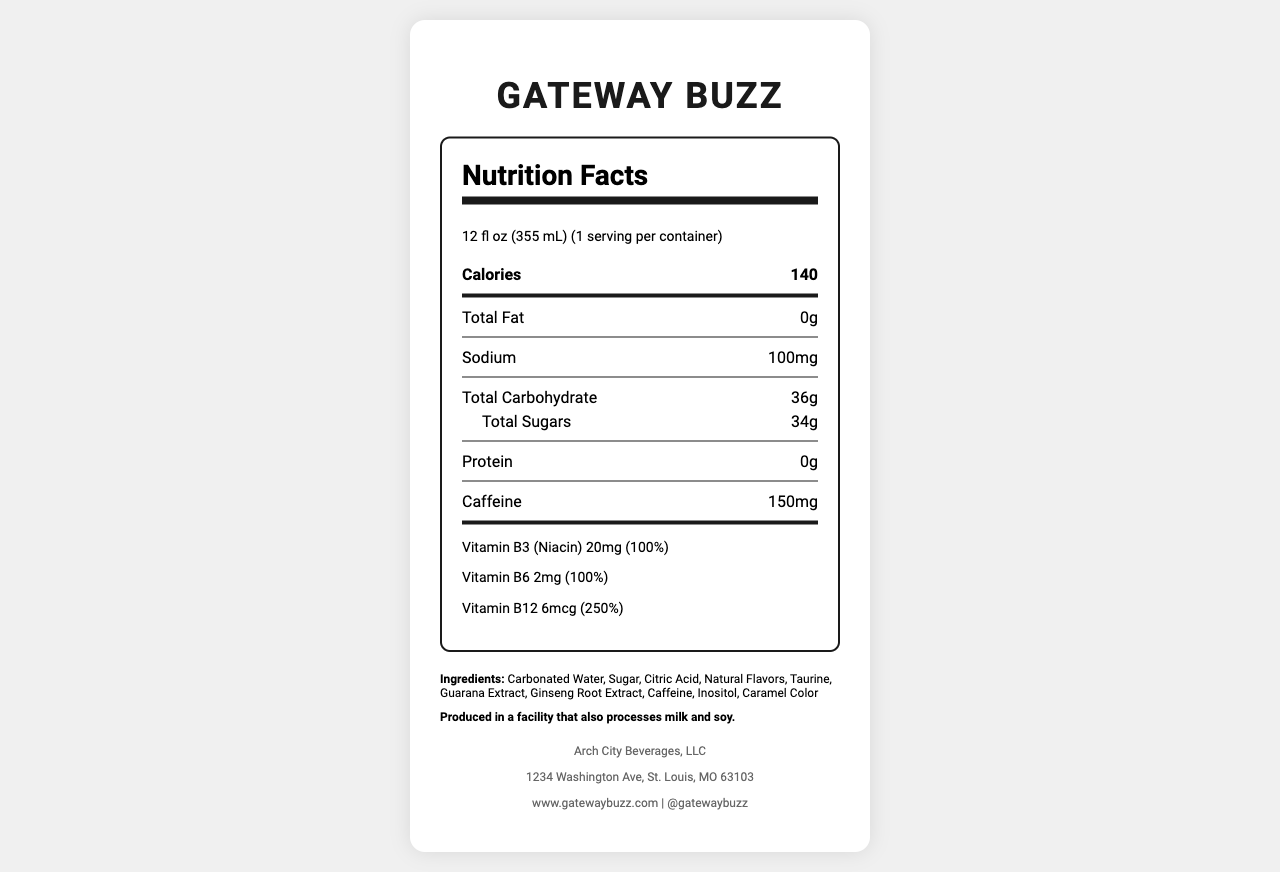what is the serving size for Gateway Buzz? The serving size is listed at the top of the Nutrition Facts section: "12 fl oz (355 mL)".
Answer: 12 fl oz (355 mL) how many servings per container are there? It says "serving per container" which is 1 next to the serving size information.
Answer: 1 how many calories are in one serving of Gateway Buzz? The number of calories is listed in bold under the serving size: "Calories 140".
Answer: 140 what is the total amount of sugars in the drink? Under the Total Carbohydrate section, it specifies "Total Sugars 34g".
Answer: 34g how much caffeine does Gateway Buzz contain? The amount of caffeine is specified separately as "Caffeine 150mg".
Answer: 150mg which vitamins are provided and at what percentage of the daily value? The Vitamins and Minerals section details the amounts and the corresponding daily values.
Answer: Vitamin B3 (Niacin) - 100%, Vitamin B6 - 100%, Vitamin B12 - 250% what are the main ingredients found in Gateway Buzz? A. Carbonated Water, B. Sugar, C. Citric Acid, D. Natural Flavors All the listed ingredients are part of the "other ingredients" section of Gateway Buzz.
Answer: all of the above what is the primary flavor profile of Gateway Buzz? A. Berry and citrus blend with ginseng hints, B. Chocolate and vanilla blend, C. Coffee and caramel blend The flavor profile is described as "Citrus and berry blend with hints of ginseng" in the text.
Answer: A does Gateway Buzz contain any dietary fiber? There is no mention of dietary fiber under the Total Carbohydrate section.
Answer: No describe the packaging of Gateway Buzz. This information is found in the packaging description.
Answer: The packaging is a 12 oz slim can featuring an artistic rendering of the Gateway Arch and Eads Bridge who is the target audience for Gateway Buzz? The target audience is directly mentioned in the document.
Answer: Creative professionals and artists in St. Louis and beyond how much protein is in Gateway Buzz? The protein content is listed as "0g" under the Nutrient section.
Answer: 0g where is the manufacturer of Gateway Buzz located? The manufacturer's address is listed at the bottom under the footer section.
Answer: 1234 Washington Ave, St. Louis, MO 63103 how many grams of carbohydrates are there in total? A. 20g, B. 25g, C. 30g, D. 36g The Total Carbohydrate amount is listed as "36g" in the document.
Answer: D is the drink produced in an allergen-free facility? The document states it is produced in a facility that also processes milk and soy.
Answer: No how many calories would be in two servings of Gateway Buzz? The document states there is only one serving per container, so this information is not provided.
Answer: Cannot be determined summarize the main idea of the document. The summary encompasses all key sections like serving size, nutrients, ingredients, packaging description, target audience, and the manufacturer’s information.
Answer: The document provides the nutrition information for Gateway Buzz, an energy drink with a St. Louis-themed packaging, targeting creative professionals. It lists nutritional values, ingredients, vitamins, and allergen information alongside packaging details and manufacturer info. 